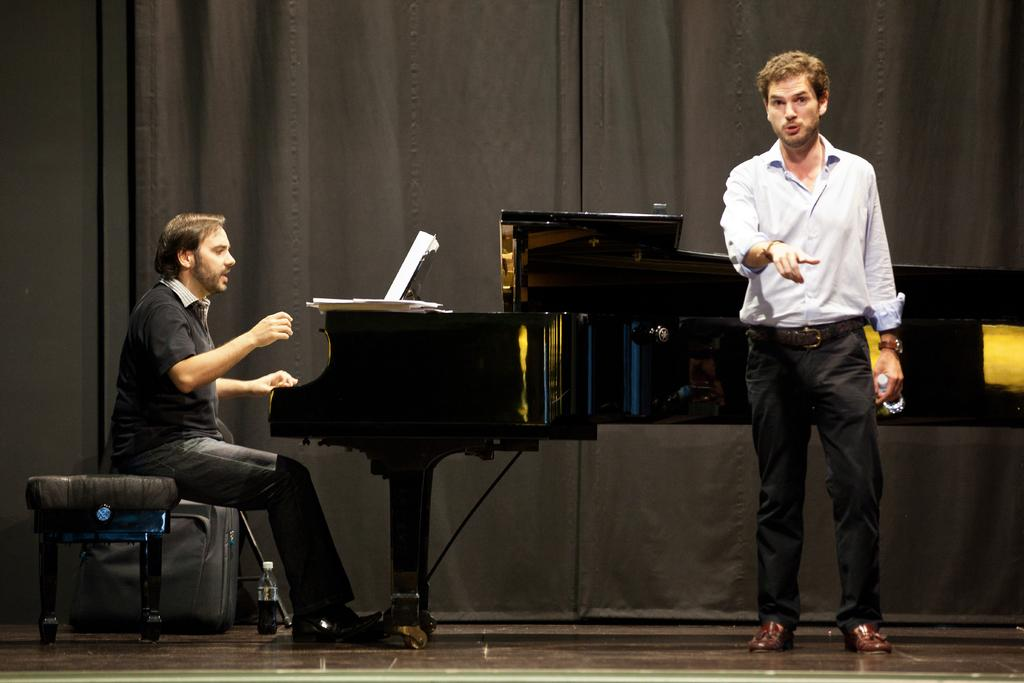What is the person in the white shirt doing in the image? The person wearing a white shirt is standing and speaking. Who is beside the person wearing a white shirt? There is another person sitting beside the person wearing a white shirt. What is the sitting person doing? The sitting person is playing the piano. What object is in front of the sitting person? There is a book in front of the sitting person. What type of wire is being used to play the piano in the image? There is no wire visible in the image, and the piano is being played by the sitting person, not a wire. 